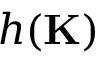Convert formula to latex. <formula><loc_0><loc_0><loc_500><loc_500>h ( K )</formula> 